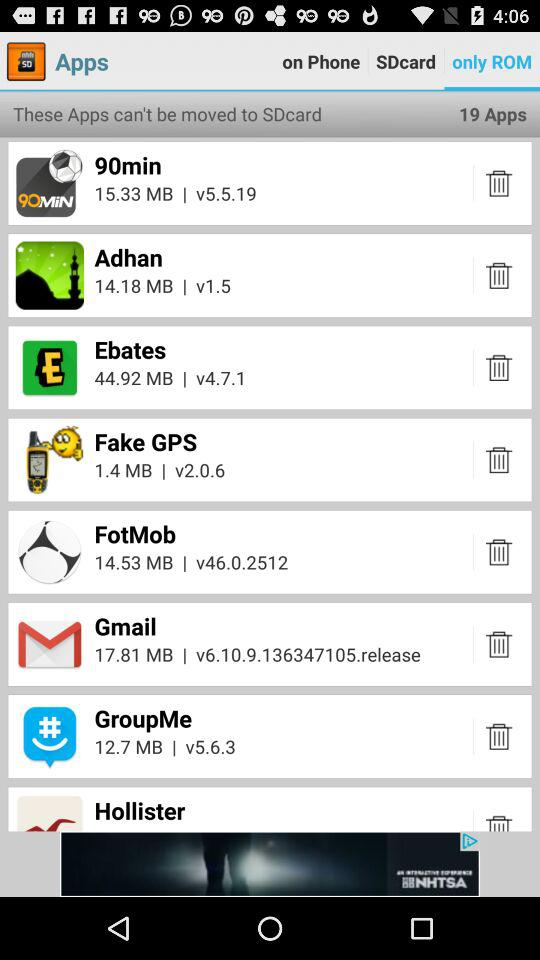What is the size of "Gmail"? The size is 17.81 MB. 